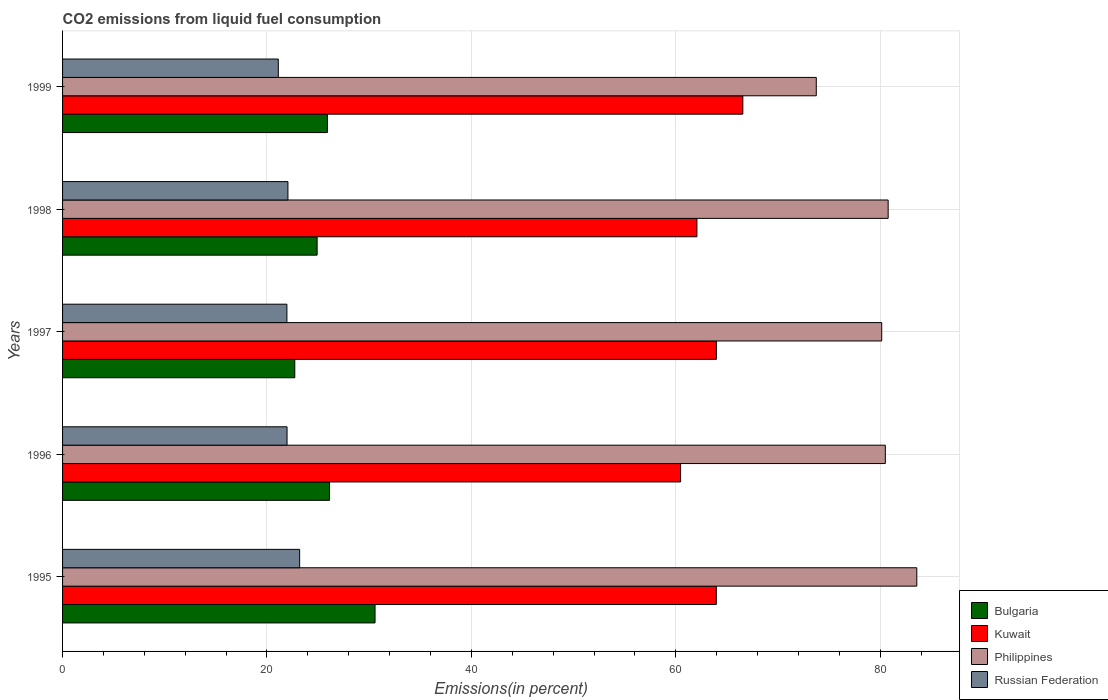How many different coloured bars are there?
Make the answer very short. 4. How many groups of bars are there?
Offer a terse response. 5. Are the number of bars per tick equal to the number of legend labels?
Your answer should be compact. Yes. Are the number of bars on each tick of the Y-axis equal?
Your answer should be very brief. Yes. How many bars are there on the 3rd tick from the top?
Provide a short and direct response. 4. In how many cases, is the number of bars for a given year not equal to the number of legend labels?
Your answer should be very brief. 0. What is the total CO2 emitted in Philippines in 1998?
Keep it short and to the point. 80.78. Across all years, what is the maximum total CO2 emitted in Bulgaria?
Keep it short and to the point. 30.57. Across all years, what is the minimum total CO2 emitted in Russian Federation?
Your answer should be very brief. 21.11. In which year was the total CO2 emitted in Kuwait maximum?
Provide a succinct answer. 1999. In which year was the total CO2 emitted in Bulgaria minimum?
Make the answer very short. 1997. What is the total total CO2 emitted in Philippines in the graph?
Your answer should be compact. 398.74. What is the difference between the total CO2 emitted in Russian Federation in 1995 and that in 1999?
Your answer should be very brief. 2.09. What is the difference between the total CO2 emitted in Bulgaria in 1996 and the total CO2 emitted in Russian Federation in 1999?
Provide a succinct answer. 5.01. What is the average total CO2 emitted in Kuwait per year?
Offer a very short reply. 63.4. In the year 1998, what is the difference between the total CO2 emitted in Russian Federation and total CO2 emitted in Philippines?
Your answer should be very brief. -58.73. What is the ratio of the total CO2 emitted in Bulgaria in 1997 to that in 1999?
Your answer should be compact. 0.88. Is the total CO2 emitted in Bulgaria in 1995 less than that in 1996?
Your answer should be very brief. No. Is the difference between the total CO2 emitted in Russian Federation in 1995 and 1999 greater than the difference between the total CO2 emitted in Philippines in 1995 and 1999?
Offer a terse response. No. What is the difference between the highest and the second highest total CO2 emitted in Russian Federation?
Provide a short and direct response. 1.14. What is the difference between the highest and the lowest total CO2 emitted in Kuwait?
Ensure brevity in your answer.  6.09. In how many years, is the total CO2 emitted in Russian Federation greater than the average total CO2 emitted in Russian Federation taken over all years?
Offer a very short reply. 1. Is the sum of the total CO2 emitted in Kuwait in 1996 and 1998 greater than the maximum total CO2 emitted in Russian Federation across all years?
Ensure brevity in your answer.  Yes. Is it the case that in every year, the sum of the total CO2 emitted in Russian Federation and total CO2 emitted in Bulgaria is greater than the sum of total CO2 emitted in Philippines and total CO2 emitted in Kuwait?
Keep it short and to the point. No. What does the 3rd bar from the top in 1996 represents?
Ensure brevity in your answer.  Kuwait. What does the 1st bar from the bottom in 1998 represents?
Offer a terse response. Bulgaria. Are the values on the major ticks of X-axis written in scientific E-notation?
Your response must be concise. No. Does the graph contain any zero values?
Your answer should be very brief. No. Does the graph contain grids?
Ensure brevity in your answer.  Yes. How many legend labels are there?
Your answer should be very brief. 4. What is the title of the graph?
Keep it short and to the point. CO2 emissions from liquid fuel consumption. Does "Gambia, The" appear as one of the legend labels in the graph?
Your response must be concise. No. What is the label or title of the X-axis?
Provide a short and direct response. Emissions(in percent). What is the label or title of the Y-axis?
Your response must be concise. Years. What is the Emissions(in percent) in Bulgaria in 1995?
Make the answer very short. 30.57. What is the Emissions(in percent) of Kuwait in 1995?
Offer a terse response. 63.96. What is the Emissions(in percent) in Philippines in 1995?
Provide a short and direct response. 83.58. What is the Emissions(in percent) of Russian Federation in 1995?
Your answer should be compact. 23.19. What is the Emissions(in percent) of Bulgaria in 1996?
Keep it short and to the point. 26.12. What is the Emissions(in percent) of Kuwait in 1996?
Provide a short and direct response. 60.47. What is the Emissions(in percent) in Philippines in 1996?
Provide a succinct answer. 80.5. What is the Emissions(in percent) in Russian Federation in 1996?
Your answer should be compact. 21.96. What is the Emissions(in percent) in Bulgaria in 1997?
Ensure brevity in your answer.  22.72. What is the Emissions(in percent) in Kuwait in 1997?
Keep it short and to the point. 63.97. What is the Emissions(in percent) in Philippines in 1997?
Provide a succinct answer. 80.14. What is the Emissions(in percent) of Russian Federation in 1997?
Your answer should be very brief. 21.95. What is the Emissions(in percent) of Bulgaria in 1998?
Your answer should be compact. 24.91. What is the Emissions(in percent) of Kuwait in 1998?
Make the answer very short. 62.07. What is the Emissions(in percent) in Philippines in 1998?
Make the answer very short. 80.78. What is the Emissions(in percent) in Russian Federation in 1998?
Your response must be concise. 22.05. What is the Emissions(in percent) in Bulgaria in 1999?
Keep it short and to the point. 25.91. What is the Emissions(in percent) of Kuwait in 1999?
Keep it short and to the point. 66.56. What is the Emissions(in percent) of Philippines in 1999?
Give a very brief answer. 73.74. What is the Emissions(in percent) of Russian Federation in 1999?
Provide a succinct answer. 21.11. Across all years, what is the maximum Emissions(in percent) of Bulgaria?
Make the answer very short. 30.57. Across all years, what is the maximum Emissions(in percent) of Kuwait?
Your answer should be compact. 66.56. Across all years, what is the maximum Emissions(in percent) of Philippines?
Make the answer very short. 83.58. Across all years, what is the maximum Emissions(in percent) of Russian Federation?
Make the answer very short. 23.19. Across all years, what is the minimum Emissions(in percent) in Bulgaria?
Make the answer very short. 22.72. Across all years, what is the minimum Emissions(in percent) in Kuwait?
Give a very brief answer. 60.47. Across all years, what is the minimum Emissions(in percent) of Philippines?
Your answer should be compact. 73.74. Across all years, what is the minimum Emissions(in percent) of Russian Federation?
Offer a terse response. 21.11. What is the total Emissions(in percent) in Bulgaria in the graph?
Your answer should be very brief. 130.23. What is the total Emissions(in percent) in Kuwait in the graph?
Keep it short and to the point. 317.02. What is the total Emissions(in percent) of Philippines in the graph?
Your answer should be very brief. 398.74. What is the total Emissions(in percent) of Russian Federation in the graph?
Your response must be concise. 110.27. What is the difference between the Emissions(in percent) of Bulgaria in 1995 and that in 1996?
Provide a succinct answer. 4.45. What is the difference between the Emissions(in percent) of Kuwait in 1995 and that in 1996?
Your answer should be very brief. 3.49. What is the difference between the Emissions(in percent) in Philippines in 1995 and that in 1996?
Your answer should be compact. 3.08. What is the difference between the Emissions(in percent) of Russian Federation in 1995 and that in 1996?
Keep it short and to the point. 1.23. What is the difference between the Emissions(in percent) in Bulgaria in 1995 and that in 1997?
Offer a terse response. 7.85. What is the difference between the Emissions(in percent) of Kuwait in 1995 and that in 1997?
Make the answer very short. -0.01. What is the difference between the Emissions(in percent) of Philippines in 1995 and that in 1997?
Offer a terse response. 3.43. What is the difference between the Emissions(in percent) in Russian Federation in 1995 and that in 1997?
Your answer should be very brief. 1.25. What is the difference between the Emissions(in percent) in Bulgaria in 1995 and that in 1998?
Give a very brief answer. 5.67. What is the difference between the Emissions(in percent) of Kuwait in 1995 and that in 1998?
Keep it short and to the point. 1.89. What is the difference between the Emissions(in percent) of Philippines in 1995 and that in 1998?
Offer a very short reply. 2.8. What is the difference between the Emissions(in percent) of Russian Federation in 1995 and that in 1998?
Make the answer very short. 1.14. What is the difference between the Emissions(in percent) of Bulgaria in 1995 and that in 1999?
Offer a very short reply. 4.66. What is the difference between the Emissions(in percent) of Kuwait in 1995 and that in 1999?
Your answer should be very brief. -2.6. What is the difference between the Emissions(in percent) in Philippines in 1995 and that in 1999?
Offer a terse response. 9.83. What is the difference between the Emissions(in percent) of Russian Federation in 1995 and that in 1999?
Offer a very short reply. 2.09. What is the difference between the Emissions(in percent) of Bulgaria in 1996 and that in 1997?
Provide a succinct answer. 3.4. What is the difference between the Emissions(in percent) in Kuwait in 1996 and that in 1997?
Provide a succinct answer. -3.5. What is the difference between the Emissions(in percent) of Philippines in 1996 and that in 1997?
Ensure brevity in your answer.  0.35. What is the difference between the Emissions(in percent) in Russian Federation in 1996 and that in 1997?
Give a very brief answer. 0.01. What is the difference between the Emissions(in percent) of Bulgaria in 1996 and that in 1998?
Your answer should be very brief. 1.22. What is the difference between the Emissions(in percent) in Kuwait in 1996 and that in 1998?
Make the answer very short. -1.6. What is the difference between the Emissions(in percent) in Philippines in 1996 and that in 1998?
Offer a very short reply. -0.28. What is the difference between the Emissions(in percent) of Russian Federation in 1996 and that in 1998?
Ensure brevity in your answer.  -0.09. What is the difference between the Emissions(in percent) of Bulgaria in 1996 and that in 1999?
Your answer should be compact. 0.21. What is the difference between the Emissions(in percent) of Kuwait in 1996 and that in 1999?
Give a very brief answer. -6.09. What is the difference between the Emissions(in percent) in Philippines in 1996 and that in 1999?
Provide a succinct answer. 6.75. What is the difference between the Emissions(in percent) in Russian Federation in 1996 and that in 1999?
Provide a succinct answer. 0.86. What is the difference between the Emissions(in percent) of Bulgaria in 1997 and that in 1998?
Offer a terse response. -2.19. What is the difference between the Emissions(in percent) of Kuwait in 1997 and that in 1998?
Give a very brief answer. 1.91. What is the difference between the Emissions(in percent) of Philippines in 1997 and that in 1998?
Ensure brevity in your answer.  -0.63. What is the difference between the Emissions(in percent) of Russian Federation in 1997 and that in 1998?
Keep it short and to the point. -0.1. What is the difference between the Emissions(in percent) in Bulgaria in 1997 and that in 1999?
Your answer should be compact. -3.19. What is the difference between the Emissions(in percent) in Kuwait in 1997 and that in 1999?
Offer a very short reply. -2.58. What is the difference between the Emissions(in percent) in Philippines in 1997 and that in 1999?
Make the answer very short. 6.4. What is the difference between the Emissions(in percent) of Russian Federation in 1997 and that in 1999?
Offer a terse response. 0.84. What is the difference between the Emissions(in percent) in Bulgaria in 1998 and that in 1999?
Offer a very short reply. -1.01. What is the difference between the Emissions(in percent) in Kuwait in 1998 and that in 1999?
Ensure brevity in your answer.  -4.49. What is the difference between the Emissions(in percent) in Philippines in 1998 and that in 1999?
Make the answer very short. 7.03. What is the difference between the Emissions(in percent) in Russian Federation in 1998 and that in 1999?
Offer a terse response. 0.94. What is the difference between the Emissions(in percent) of Bulgaria in 1995 and the Emissions(in percent) of Kuwait in 1996?
Keep it short and to the point. -29.89. What is the difference between the Emissions(in percent) in Bulgaria in 1995 and the Emissions(in percent) in Philippines in 1996?
Provide a short and direct response. -49.93. What is the difference between the Emissions(in percent) in Bulgaria in 1995 and the Emissions(in percent) in Russian Federation in 1996?
Your answer should be compact. 8.61. What is the difference between the Emissions(in percent) in Kuwait in 1995 and the Emissions(in percent) in Philippines in 1996?
Keep it short and to the point. -16.54. What is the difference between the Emissions(in percent) of Kuwait in 1995 and the Emissions(in percent) of Russian Federation in 1996?
Ensure brevity in your answer.  42. What is the difference between the Emissions(in percent) of Philippines in 1995 and the Emissions(in percent) of Russian Federation in 1996?
Keep it short and to the point. 61.61. What is the difference between the Emissions(in percent) in Bulgaria in 1995 and the Emissions(in percent) in Kuwait in 1997?
Your answer should be compact. -33.4. What is the difference between the Emissions(in percent) in Bulgaria in 1995 and the Emissions(in percent) in Philippines in 1997?
Provide a short and direct response. -49.57. What is the difference between the Emissions(in percent) of Bulgaria in 1995 and the Emissions(in percent) of Russian Federation in 1997?
Give a very brief answer. 8.62. What is the difference between the Emissions(in percent) of Kuwait in 1995 and the Emissions(in percent) of Philippines in 1997?
Provide a succinct answer. -16.18. What is the difference between the Emissions(in percent) of Kuwait in 1995 and the Emissions(in percent) of Russian Federation in 1997?
Keep it short and to the point. 42.01. What is the difference between the Emissions(in percent) of Philippines in 1995 and the Emissions(in percent) of Russian Federation in 1997?
Make the answer very short. 61.63. What is the difference between the Emissions(in percent) of Bulgaria in 1995 and the Emissions(in percent) of Kuwait in 1998?
Provide a succinct answer. -31.49. What is the difference between the Emissions(in percent) of Bulgaria in 1995 and the Emissions(in percent) of Philippines in 1998?
Keep it short and to the point. -50.2. What is the difference between the Emissions(in percent) of Bulgaria in 1995 and the Emissions(in percent) of Russian Federation in 1998?
Your answer should be compact. 8.52. What is the difference between the Emissions(in percent) of Kuwait in 1995 and the Emissions(in percent) of Philippines in 1998?
Your answer should be very brief. -16.82. What is the difference between the Emissions(in percent) of Kuwait in 1995 and the Emissions(in percent) of Russian Federation in 1998?
Your answer should be very brief. 41.91. What is the difference between the Emissions(in percent) of Philippines in 1995 and the Emissions(in percent) of Russian Federation in 1998?
Provide a succinct answer. 61.53. What is the difference between the Emissions(in percent) in Bulgaria in 1995 and the Emissions(in percent) in Kuwait in 1999?
Your response must be concise. -35.98. What is the difference between the Emissions(in percent) of Bulgaria in 1995 and the Emissions(in percent) of Philippines in 1999?
Ensure brevity in your answer.  -43.17. What is the difference between the Emissions(in percent) of Bulgaria in 1995 and the Emissions(in percent) of Russian Federation in 1999?
Offer a terse response. 9.46. What is the difference between the Emissions(in percent) in Kuwait in 1995 and the Emissions(in percent) in Philippines in 1999?
Offer a terse response. -9.78. What is the difference between the Emissions(in percent) in Kuwait in 1995 and the Emissions(in percent) in Russian Federation in 1999?
Your answer should be very brief. 42.85. What is the difference between the Emissions(in percent) in Philippines in 1995 and the Emissions(in percent) in Russian Federation in 1999?
Offer a terse response. 62.47. What is the difference between the Emissions(in percent) of Bulgaria in 1996 and the Emissions(in percent) of Kuwait in 1997?
Your answer should be very brief. -37.85. What is the difference between the Emissions(in percent) in Bulgaria in 1996 and the Emissions(in percent) in Philippines in 1997?
Your response must be concise. -54.02. What is the difference between the Emissions(in percent) in Bulgaria in 1996 and the Emissions(in percent) in Russian Federation in 1997?
Give a very brief answer. 4.17. What is the difference between the Emissions(in percent) of Kuwait in 1996 and the Emissions(in percent) of Philippines in 1997?
Provide a short and direct response. -19.68. What is the difference between the Emissions(in percent) in Kuwait in 1996 and the Emissions(in percent) in Russian Federation in 1997?
Your response must be concise. 38.52. What is the difference between the Emissions(in percent) of Philippines in 1996 and the Emissions(in percent) of Russian Federation in 1997?
Keep it short and to the point. 58.55. What is the difference between the Emissions(in percent) in Bulgaria in 1996 and the Emissions(in percent) in Kuwait in 1998?
Keep it short and to the point. -35.94. What is the difference between the Emissions(in percent) of Bulgaria in 1996 and the Emissions(in percent) of Philippines in 1998?
Your answer should be compact. -54.65. What is the difference between the Emissions(in percent) in Bulgaria in 1996 and the Emissions(in percent) in Russian Federation in 1998?
Offer a terse response. 4.07. What is the difference between the Emissions(in percent) in Kuwait in 1996 and the Emissions(in percent) in Philippines in 1998?
Your answer should be compact. -20.31. What is the difference between the Emissions(in percent) of Kuwait in 1996 and the Emissions(in percent) of Russian Federation in 1998?
Offer a very short reply. 38.42. What is the difference between the Emissions(in percent) in Philippines in 1996 and the Emissions(in percent) in Russian Federation in 1998?
Your response must be concise. 58.45. What is the difference between the Emissions(in percent) of Bulgaria in 1996 and the Emissions(in percent) of Kuwait in 1999?
Provide a short and direct response. -40.43. What is the difference between the Emissions(in percent) in Bulgaria in 1996 and the Emissions(in percent) in Philippines in 1999?
Offer a terse response. -47.62. What is the difference between the Emissions(in percent) in Bulgaria in 1996 and the Emissions(in percent) in Russian Federation in 1999?
Your response must be concise. 5.01. What is the difference between the Emissions(in percent) of Kuwait in 1996 and the Emissions(in percent) of Philippines in 1999?
Your response must be concise. -13.28. What is the difference between the Emissions(in percent) of Kuwait in 1996 and the Emissions(in percent) of Russian Federation in 1999?
Provide a short and direct response. 39.36. What is the difference between the Emissions(in percent) in Philippines in 1996 and the Emissions(in percent) in Russian Federation in 1999?
Offer a very short reply. 59.39. What is the difference between the Emissions(in percent) of Bulgaria in 1997 and the Emissions(in percent) of Kuwait in 1998?
Offer a terse response. -39.35. What is the difference between the Emissions(in percent) of Bulgaria in 1997 and the Emissions(in percent) of Philippines in 1998?
Give a very brief answer. -58.06. What is the difference between the Emissions(in percent) of Bulgaria in 1997 and the Emissions(in percent) of Russian Federation in 1998?
Keep it short and to the point. 0.67. What is the difference between the Emissions(in percent) of Kuwait in 1997 and the Emissions(in percent) of Philippines in 1998?
Your answer should be compact. -16.8. What is the difference between the Emissions(in percent) of Kuwait in 1997 and the Emissions(in percent) of Russian Federation in 1998?
Provide a succinct answer. 41.92. What is the difference between the Emissions(in percent) in Philippines in 1997 and the Emissions(in percent) in Russian Federation in 1998?
Give a very brief answer. 58.09. What is the difference between the Emissions(in percent) in Bulgaria in 1997 and the Emissions(in percent) in Kuwait in 1999?
Your answer should be very brief. -43.84. What is the difference between the Emissions(in percent) in Bulgaria in 1997 and the Emissions(in percent) in Philippines in 1999?
Your response must be concise. -51.02. What is the difference between the Emissions(in percent) of Bulgaria in 1997 and the Emissions(in percent) of Russian Federation in 1999?
Provide a short and direct response. 1.61. What is the difference between the Emissions(in percent) in Kuwait in 1997 and the Emissions(in percent) in Philippines in 1999?
Provide a short and direct response. -9.77. What is the difference between the Emissions(in percent) of Kuwait in 1997 and the Emissions(in percent) of Russian Federation in 1999?
Offer a terse response. 42.86. What is the difference between the Emissions(in percent) of Philippines in 1997 and the Emissions(in percent) of Russian Federation in 1999?
Make the answer very short. 59.04. What is the difference between the Emissions(in percent) in Bulgaria in 1998 and the Emissions(in percent) in Kuwait in 1999?
Offer a very short reply. -41.65. What is the difference between the Emissions(in percent) of Bulgaria in 1998 and the Emissions(in percent) of Philippines in 1999?
Your response must be concise. -48.84. What is the difference between the Emissions(in percent) of Bulgaria in 1998 and the Emissions(in percent) of Russian Federation in 1999?
Make the answer very short. 3.8. What is the difference between the Emissions(in percent) in Kuwait in 1998 and the Emissions(in percent) in Philippines in 1999?
Provide a succinct answer. -11.68. What is the difference between the Emissions(in percent) in Kuwait in 1998 and the Emissions(in percent) in Russian Federation in 1999?
Your answer should be very brief. 40.96. What is the difference between the Emissions(in percent) in Philippines in 1998 and the Emissions(in percent) in Russian Federation in 1999?
Ensure brevity in your answer.  59.67. What is the average Emissions(in percent) of Bulgaria per year?
Make the answer very short. 26.05. What is the average Emissions(in percent) of Kuwait per year?
Keep it short and to the point. 63.4. What is the average Emissions(in percent) of Philippines per year?
Keep it short and to the point. 79.75. What is the average Emissions(in percent) in Russian Federation per year?
Your answer should be very brief. 22.05. In the year 1995, what is the difference between the Emissions(in percent) of Bulgaria and Emissions(in percent) of Kuwait?
Offer a terse response. -33.39. In the year 1995, what is the difference between the Emissions(in percent) of Bulgaria and Emissions(in percent) of Philippines?
Give a very brief answer. -53. In the year 1995, what is the difference between the Emissions(in percent) in Bulgaria and Emissions(in percent) in Russian Federation?
Your answer should be very brief. 7.38. In the year 1995, what is the difference between the Emissions(in percent) of Kuwait and Emissions(in percent) of Philippines?
Keep it short and to the point. -19.62. In the year 1995, what is the difference between the Emissions(in percent) in Kuwait and Emissions(in percent) in Russian Federation?
Provide a succinct answer. 40.77. In the year 1995, what is the difference between the Emissions(in percent) in Philippines and Emissions(in percent) in Russian Federation?
Give a very brief answer. 60.38. In the year 1996, what is the difference between the Emissions(in percent) of Bulgaria and Emissions(in percent) of Kuwait?
Keep it short and to the point. -34.34. In the year 1996, what is the difference between the Emissions(in percent) in Bulgaria and Emissions(in percent) in Philippines?
Your response must be concise. -54.38. In the year 1996, what is the difference between the Emissions(in percent) of Bulgaria and Emissions(in percent) of Russian Federation?
Provide a succinct answer. 4.16. In the year 1996, what is the difference between the Emissions(in percent) of Kuwait and Emissions(in percent) of Philippines?
Your answer should be very brief. -20.03. In the year 1996, what is the difference between the Emissions(in percent) of Kuwait and Emissions(in percent) of Russian Federation?
Offer a very short reply. 38.5. In the year 1996, what is the difference between the Emissions(in percent) in Philippines and Emissions(in percent) in Russian Federation?
Offer a terse response. 58.53. In the year 1997, what is the difference between the Emissions(in percent) in Bulgaria and Emissions(in percent) in Kuwait?
Your answer should be compact. -41.25. In the year 1997, what is the difference between the Emissions(in percent) in Bulgaria and Emissions(in percent) in Philippines?
Offer a very short reply. -57.42. In the year 1997, what is the difference between the Emissions(in percent) of Bulgaria and Emissions(in percent) of Russian Federation?
Your answer should be very brief. 0.77. In the year 1997, what is the difference between the Emissions(in percent) of Kuwait and Emissions(in percent) of Philippines?
Provide a short and direct response. -16.17. In the year 1997, what is the difference between the Emissions(in percent) of Kuwait and Emissions(in percent) of Russian Federation?
Your answer should be compact. 42.02. In the year 1997, what is the difference between the Emissions(in percent) in Philippines and Emissions(in percent) in Russian Federation?
Provide a short and direct response. 58.2. In the year 1998, what is the difference between the Emissions(in percent) of Bulgaria and Emissions(in percent) of Kuwait?
Provide a short and direct response. -37.16. In the year 1998, what is the difference between the Emissions(in percent) of Bulgaria and Emissions(in percent) of Philippines?
Your answer should be compact. -55.87. In the year 1998, what is the difference between the Emissions(in percent) of Bulgaria and Emissions(in percent) of Russian Federation?
Ensure brevity in your answer.  2.86. In the year 1998, what is the difference between the Emissions(in percent) in Kuwait and Emissions(in percent) in Philippines?
Offer a terse response. -18.71. In the year 1998, what is the difference between the Emissions(in percent) in Kuwait and Emissions(in percent) in Russian Federation?
Offer a terse response. 40.02. In the year 1998, what is the difference between the Emissions(in percent) in Philippines and Emissions(in percent) in Russian Federation?
Provide a succinct answer. 58.73. In the year 1999, what is the difference between the Emissions(in percent) in Bulgaria and Emissions(in percent) in Kuwait?
Offer a very short reply. -40.64. In the year 1999, what is the difference between the Emissions(in percent) of Bulgaria and Emissions(in percent) of Philippines?
Ensure brevity in your answer.  -47.83. In the year 1999, what is the difference between the Emissions(in percent) in Bulgaria and Emissions(in percent) in Russian Federation?
Give a very brief answer. 4.8. In the year 1999, what is the difference between the Emissions(in percent) of Kuwait and Emissions(in percent) of Philippines?
Ensure brevity in your answer.  -7.19. In the year 1999, what is the difference between the Emissions(in percent) of Kuwait and Emissions(in percent) of Russian Federation?
Provide a succinct answer. 45.45. In the year 1999, what is the difference between the Emissions(in percent) of Philippines and Emissions(in percent) of Russian Federation?
Offer a very short reply. 52.64. What is the ratio of the Emissions(in percent) in Bulgaria in 1995 to that in 1996?
Offer a terse response. 1.17. What is the ratio of the Emissions(in percent) in Kuwait in 1995 to that in 1996?
Make the answer very short. 1.06. What is the ratio of the Emissions(in percent) in Philippines in 1995 to that in 1996?
Your response must be concise. 1.04. What is the ratio of the Emissions(in percent) of Russian Federation in 1995 to that in 1996?
Provide a succinct answer. 1.06. What is the ratio of the Emissions(in percent) in Bulgaria in 1995 to that in 1997?
Give a very brief answer. 1.35. What is the ratio of the Emissions(in percent) of Kuwait in 1995 to that in 1997?
Keep it short and to the point. 1. What is the ratio of the Emissions(in percent) in Philippines in 1995 to that in 1997?
Provide a succinct answer. 1.04. What is the ratio of the Emissions(in percent) of Russian Federation in 1995 to that in 1997?
Offer a terse response. 1.06. What is the ratio of the Emissions(in percent) of Bulgaria in 1995 to that in 1998?
Make the answer very short. 1.23. What is the ratio of the Emissions(in percent) of Kuwait in 1995 to that in 1998?
Give a very brief answer. 1.03. What is the ratio of the Emissions(in percent) in Philippines in 1995 to that in 1998?
Your answer should be very brief. 1.03. What is the ratio of the Emissions(in percent) of Russian Federation in 1995 to that in 1998?
Give a very brief answer. 1.05. What is the ratio of the Emissions(in percent) in Bulgaria in 1995 to that in 1999?
Keep it short and to the point. 1.18. What is the ratio of the Emissions(in percent) of Philippines in 1995 to that in 1999?
Offer a very short reply. 1.13. What is the ratio of the Emissions(in percent) of Russian Federation in 1995 to that in 1999?
Your answer should be very brief. 1.1. What is the ratio of the Emissions(in percent) in Bulgaria in 1996 to that in 1997?
Ensure brevity in your answer.  1.15. What is the ratio of the Emissions(in percent) in Kuwait in 1996 to that in 1997?
Ensure brevity in your answer.  0.95. What is the ratio of the Emissions(in percent) in Philippines in 1996 to that in 1997?
Make the answer very short. 1. What is the ratio of the Emissions(in percent) of Russian Federation in 1996 to that in 1997?
Provide a short and direct response. 1. What is the ratio of the Emissions(in percent) in Bulgaria in 1996 to that in 1998?
Your answer should be compact. 1.05. What is the ratio of the Emissions(in percent) in Kuwait in 1996 to that in 1998?
Offer a very short reply. 0.97. What is the ratio of the Emissions(in percent) of Philippines in 1996 to that in 1998?
Keep it short and to the point. 1. What is the ratio of the Emissions(in percent) in Kuwait in 1996 to that in 1999?
Your response must be concise. 0.91. What is the ratio of the Emissions(in percent) in Philippines in 1996 to that in 1999?
Provide a succinct answer. 1.09. What is the ratio of the Emissions(in percent) in Russian Federation in 1996 to that in 1999?
Give a very brief answer. 1.04. What is the ratio of the Emissions(in percent) of Bulgaria in 1997 to that in 1998?
Offer a terse response. 0.91. What is the ratio of the Emissions(in percent) of Kuwait in 1997 to that in 1998?
Your response must be concise. 1.03. What is the ratio of the Emissions(in percent) in Philippines in 1997 to that in 1998?
Offer a very short reply. 0.99. What is the ratio of the Emissions(in percent) of Russian Federation in 1997 to that in 1998?
Offer a terse response. 1. What is the ratio of the Emissions(in percent) of Bulgaria in 1997 to that in 1999?
Provide a succinct answer. 0.88. What is the ratio of the Emissions(in percent) of Kuwait in 1997 to that in 1999?
Make the answer very short. 0.96. What is the ratio of the Emissions(in percent) of Philippines in 1997 to that in 1999?
Offer a very short reply. 1.09. What is the ratio of the Emissions(in percent) in Russian Federation in 1997 to that in 1999?
Your answer should be compact. 1.04. What is the ratio of the Emissions(in percent) of Bulgaria in 1998 to that in 1999?
Make the answer very short. 0.96. What is the ratio of the Emissions(in percent) in Kuwait in 1998 to that in 1999?
Your answer should be very brief. 0.93. What is the ratio of the Emissions(in percent) in Philippines in 1998 to that in 1999?
Ensure brevity in your answer.  1.1. What is the ratio of the Emissions(in percent) of Russian Federation in 1998 to that in 1999?
Ensure brevity in your answer.  1.04. What is the difference between the highest and the second highest Emissions(in percent) of Bulgaria?
Offer a terse response. 4.45. What is the difference between the highest and the second highest Emissions(in percent) of Kuwait?
Your answer should be very brief. 2.58. What is the difference between the highest and the second highest Emissions(in percent) in Philippines?
Provide a short and direct response. 2.8. What is the difference between the highest and the second highest Emissions(in percent) of Russian Federation?
Keep it short and to the point. 1.14. What is the difference between the highest and the lowest Emissions(in percent) of Bulgaria?
Give a very brief answer. 7.85. What is the difference between the highest and the lowest Emissions(in percent) of Kuwait?
Your response must be concise. 6.09. What is the difference between the highest and the lowest Emissions(in percent) in Philippines?
Offer a very short reply. 9.83. What is the difference between the highest and the lowest Emissions(in percent) in Russian Federation?
Keep it short and to the point. 2.09. 